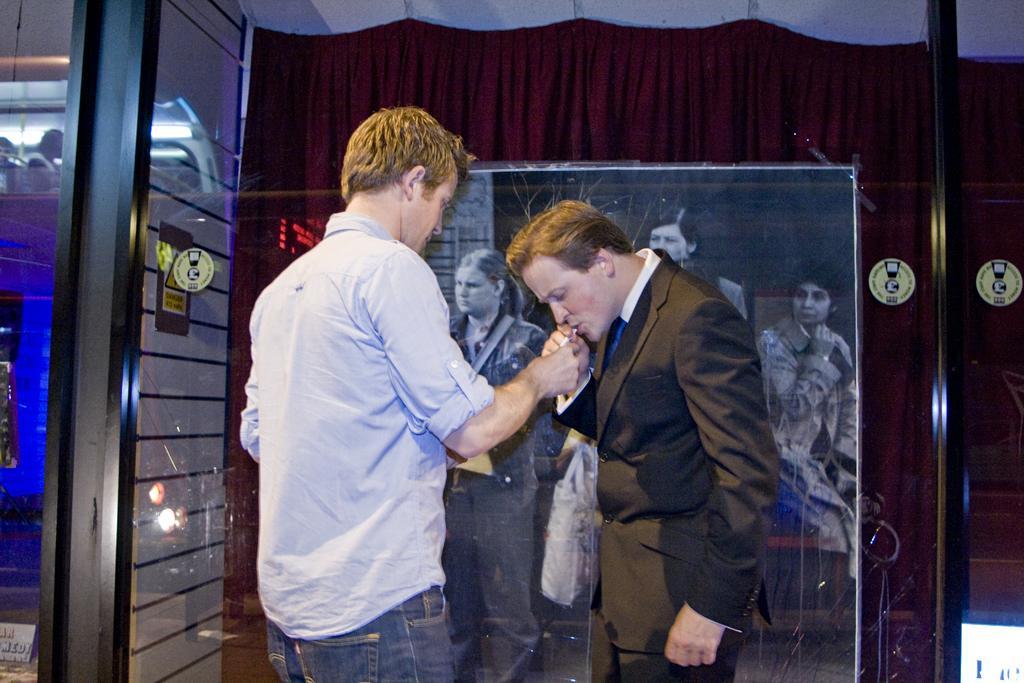Can you describe this image briefly? In this image we can see men standing on the floor. In the background there are a black and white picture attached to the curtain, doors and electric lights. 